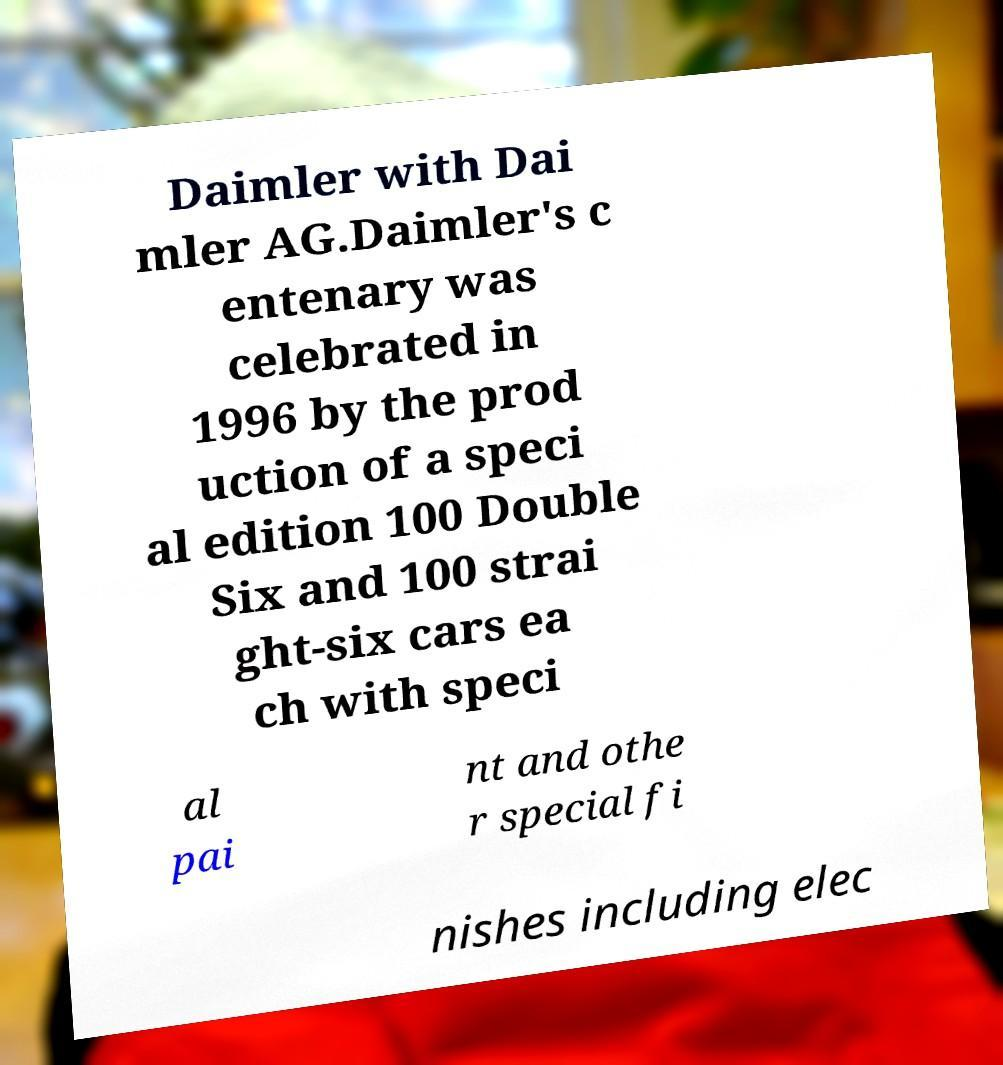Please read and relay the text visible in this image. What does it say? Daimler with Dai mler AG.Daimler's c entenary was celebrated in 1996 by the prod uction of a speci al edition 100 Double Six and 100 strai ght-six cars ea ch with speci al pai nt and othe r special fi nishes including elec 